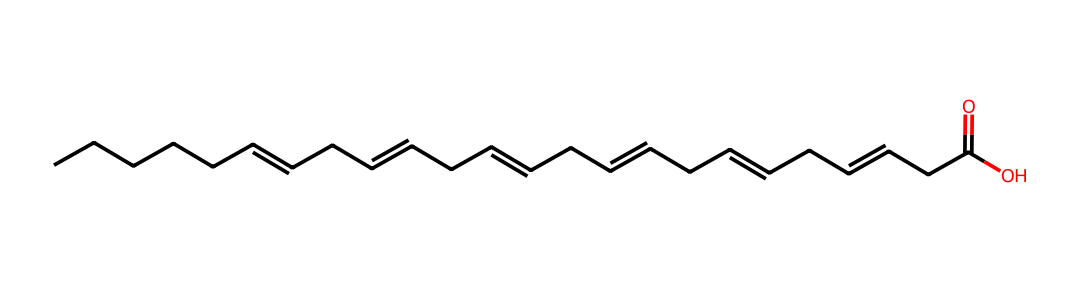How many carbon atoms are present in DHA? The SMILES representation shows a long hydrocarbon chain; counting the "C" symbols in the structure reveals there are 22 carbon atoms in total.
Answer: 22 How many double bonds does DHA have? By examining the structure, the notation “C=C” indicates double carbon-carbon bonds. There are six double bonds in the chain, as evident from the positioning of the equal signs.
Answer: 6 What is the primary function of DHA in the human body? DHA is particularly crucial for brain function and eye health, as it is a major structural component of the human brain and retina, contributing to cognitive and visual development.
Answer: brain function What type of fatty acid is DHA classified as? DHA is classified as an omega-3 fatty acid, as indicated by the presence of the first double bond in relation to the third carbon from the methyl end of the hydrocarbon chain.
Answer: omega-3 What molecule does DHA primarily form when it undergoes esterification? DHA can form triglycerides when it undergoes esterification with glycerol, as it has carboxylic acid functional group indicated by "C(=O)O" at the end of the chain.
Answer: triglycerides How does the structure of DHA affect its fluidity in cellular membranes? The presence of multiple double bonds introduces kinks in the fatty acid chain, which prevents tight packing of the molecules, thereby increasing fluidity in cellular membranes.
Answer: increases fluidity What is the impact of DHA deficiency in humans? A deficiency in DHA can lead to cognitive decline, vision problems, and other neurological issues, as DHA is critical for maintaining healthy brain and retinal function.
Answer: cognitive decline 